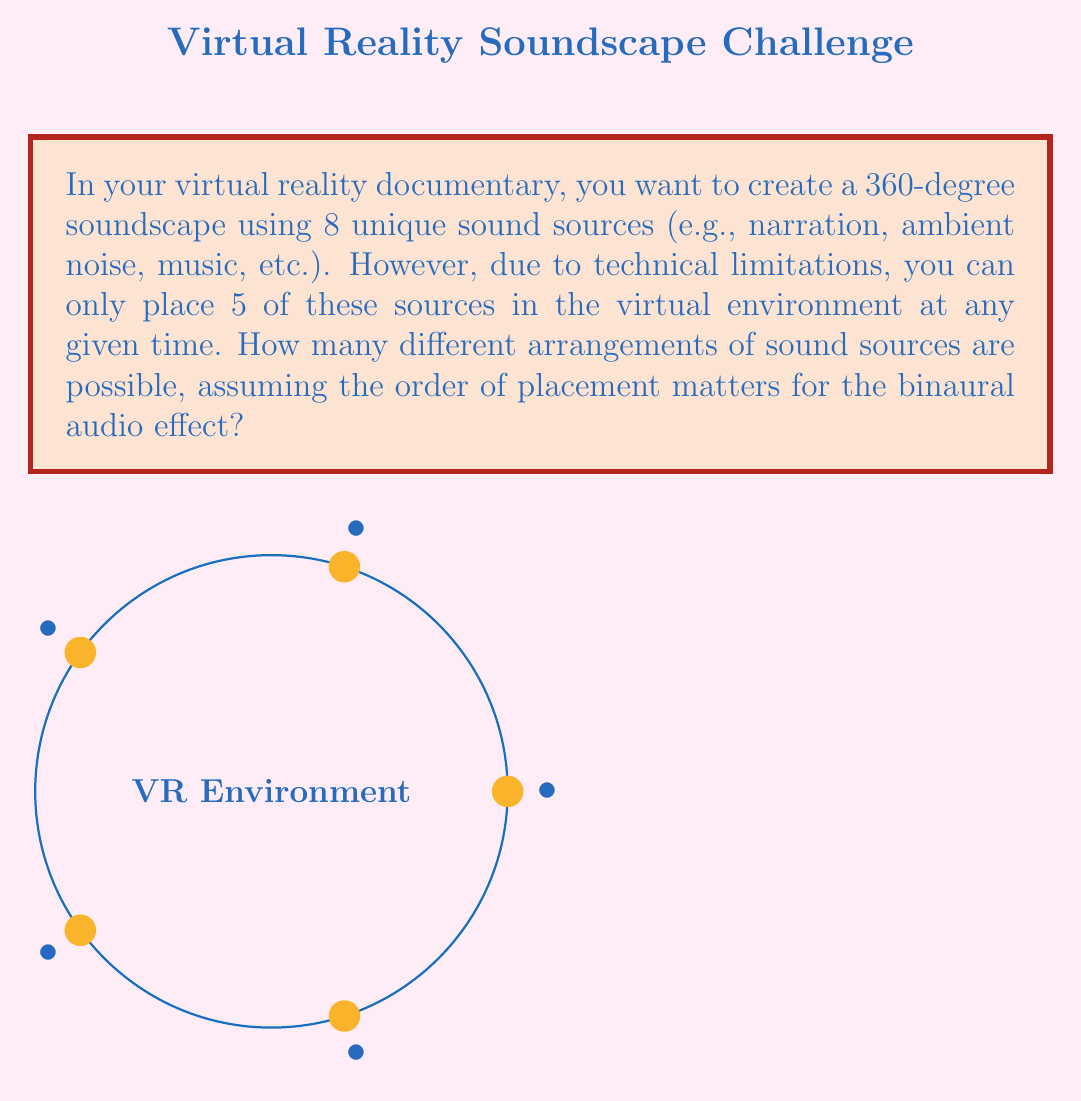What is the answer to this math problem? To solve this problem, we need to use the concept of permutations from Group theory. Here's a step-by-step explanation:

1) First, we need to choose 5 sound sources out of the 8 available. This is a combination problem, denoted as $\binom{8}{5}$.

2) The number of ways to choose 5 items from 8 is calculated as:

   $$\binom{8}{5} = \frac{8!}{5!(8-5)!} = \frac{8!}{5!3!} = 56$$

3) Once we have chosen 5 sound sources, we need to arrange them in the virtual environment. Since the order matters for the binaural audio effect, this is a permutation of 5 items.

4) The number of permutations of 5 items is simply 5!, which is:

   $$5! = 5 \times 4 \times 3 \times 2 \times 1 = 120$$

5) By the multiplication principle, the total number of unique arrangements is the product of the number of ways to choose 5 sources and the number of ways to arrange them:

   $$\text{Total arrangements} = \binom{8}{5} \times 5! = 56 \times 120 = 6720$$

Therefore, there are 6720 different possible arrangements of sound sources in your virtual environment.
Answer: 6720 